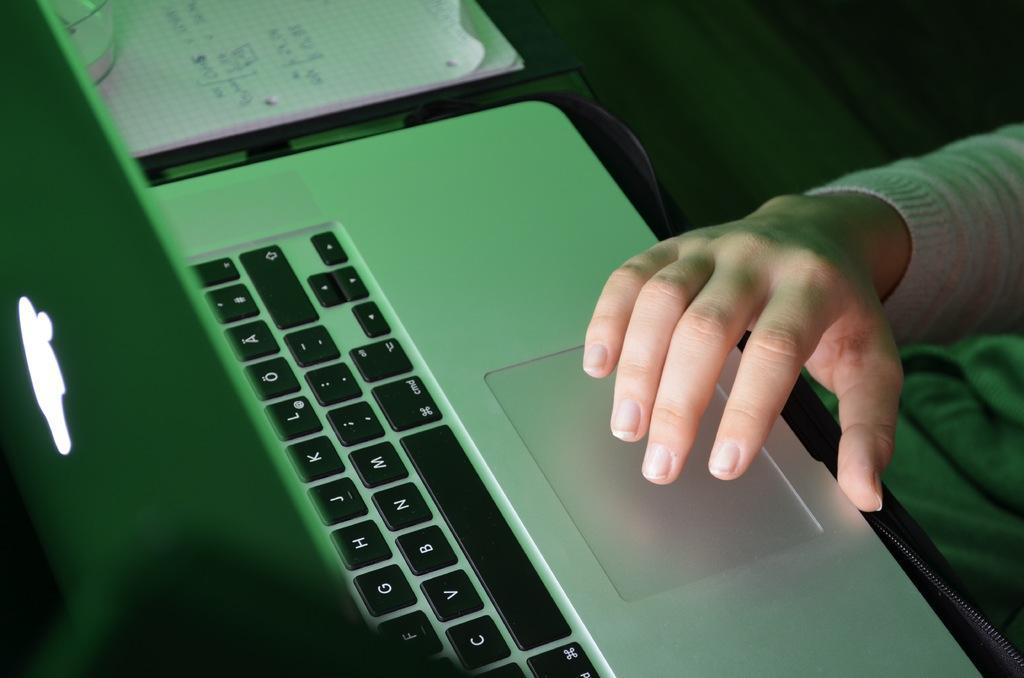Please provide a concise description of this image. On the right side of the image we can see the hand of a person. In front of the hand, we can see one laptop, papers and one object on the papers. And we can see the dark background. 